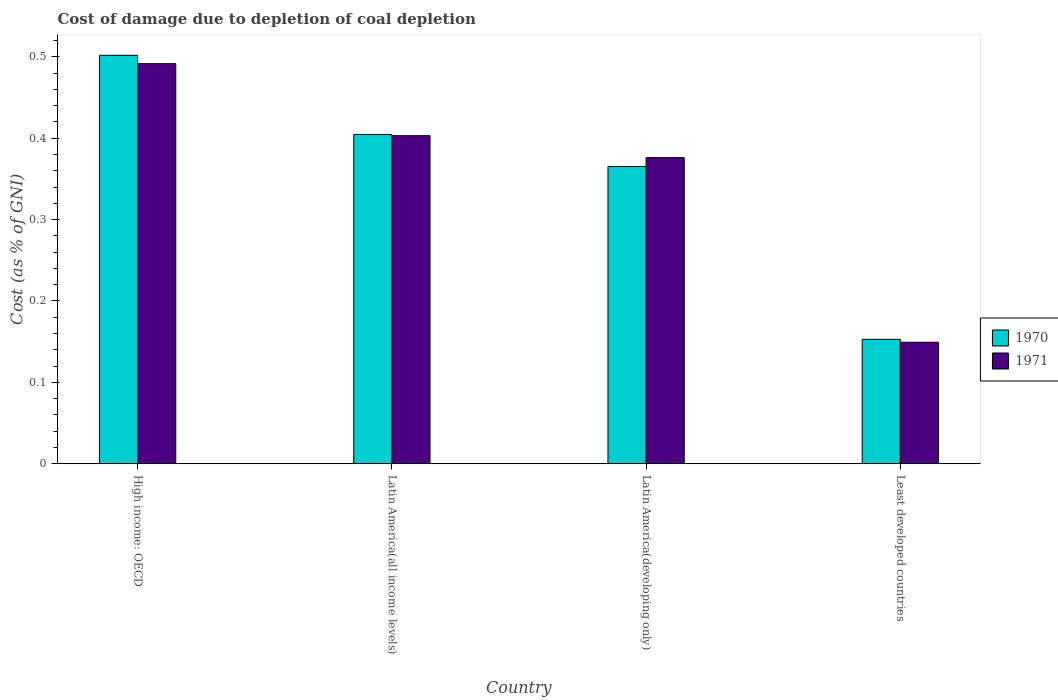How many groups of bars are there?
Ensure brevity in your answer.  4. What is the label of the 3rd group of bars from the left?
Keep it short and to the point. Latin America(developing only). In how many cases, is the number of bars for a given country not equal to the number of legend labels?
Offer a terse response. 0. What is the cost of damage caused due to coal depletion in 1971 in Latin America(all income levels)?
Make the answer very short. 0.4. Across all countries, what is the maximum cost of damage caused due to coal depletion in 1970?
Your answer should be compact. 0.5. Across all countries, what is the minimum cost of damage caused due to coal depletion in 1971?
Provide a succinct answer. 0.15. In which country was the cost of damage caused due to coal depletion in 1970 maximum?
Ensure brevity in your answer.  High income: OECD. In which country was the cost of damage caused due to coal depletion in 1971 minimum?
Ensure brevity in your answer.  Least developed countries. What is the total cost of damage caused due to coal depletion in 1971 in the graph?
Offer a very short reply. 1.42. What is the difference between the cost of damage caused due to coal depletion in 1970 in High income: OECD and that in Latin America(developing only)?
Keep it short and to the point. 0.14. What is the difference between the cost of damage caused due to coal depletion in 1970 in Latin America(all income levels) and the cost of damage caused due to coal depletion in 1971 in Latin America(developing only)?
Make the answer very short. 0.03. What is the average cost of damage caused due to coal depletion in 1971 per country?
Give a very brief answer. 0.35. What is the difference between the cost of damage caused due to coal depletion of/in 1970 and cost of damage caused due to coal depletion of/in 1971 in High income: OECD?
Make the answer very short. 0.01. In how many countries, is the cost of damage caused due to coal depletion in 1970 greater than 0.36000000000000004 %?
Ensure brevity in your answer.  3. What is the ratio of the cost of damage caused due to coal depletion in 1971 in Latin America(developing only) to that in Least developed countries?
Keep it short and to the point. 2.52. Is the cost of damage caused due to coal depletion in 1970 in High income: OECD less than that in Least developed countries?
Provide a short and direct response. No. What is the difference between the highest and the second highest cost of damage caused due to coal depletion in 1970?
Make the answer very short. 0.1. What is the difference between the highest and the lowest cost of damage caused due to coal depletion in 1971?
Your response must be concise. 0.34. In how many countries, is the cost of damage caused due to coal depletion in 1970 greater than the average cost of damage caused due to coal depletion in 1970 taken over all countries?
Offer a very short reply. 3. What does the 1st bar from the left in Least developed countries represents?
Your answer should be very brief. 1970. What does the 1st bar from the right in Latin America(developing only) represents?
Provide a succinct answer. 1971. How many bars are there?
Provide a short and direct response. 8. Are all the bars in the graph horizontal?
Offer a very short reply. No. How many countries are there in the graph?
Your answer should be compact. 4. Does the graph contain any zero values?
Give a very brief answer. No. Does the graph contain grids?
Your response must be concise. No. How many legend labels are there?
Your answer should be compact. 2. How are the legend labels stacked?
Give a very brief answer. Vertical. What is the title of the graph?
Provide a short and direct response. Cost of damage due to depletion of coal depletion. What is the label or title of the Y-axis?
Offer a very short reply. Cost (as % of GNI). What is the Cost (as % of GNI) of 1970 in High income: OECD?
Make the answer very short. 0.5. What is the Cost (as % of GNI) of 1971 in High income: OECD?
Ensure brevity in your answer.  0.49. What is the Cost (as % of GNI) in 1970 in Latin America(all income levels)?
Ensure brevity in your answer.  0.4. What is the Cost (as % of GNI) in 1971 in Latin America(all income levels)?
Offer a terse response. 0.4. What is the Cost (as % of GNI) of 1970 in Latin America(developing only)?
Provide a succinct answer. 0.37. What is the Cost (as % of GNI) of 1971 in Latin America(developing only)?
Keep it short and to the point. 0.38. What is the Cost (as % of GNI) in 1970 in Least developed countries?
Give a very brief answer. 0.15. What is the Cost (as % of GNI) in 1971 in Least developed countries?
Offer a very short reply. 0.15. Across all countries, what is the maximum Cost (as % of GNI) of 1970?
Your answer should be compact. 0.5. Across all countries, what is the maximum Cost (as % of GNI) of 1971?
Make the answer very short. 0.49. Across all countries, what is the minimum Cost (as % of GNI) in 1970?
Make the answer very short. 0.15. Across all countries, what is the minimum Cost (as % of GNI) in 1971?
Your answer should be compact. 0.15. What is the total Cost (as % of GNI) in 1970 in the graph?
Offer a terse response. 1.42. What is the total Cost (as % of GNI) in 1971 in the graph?
Ensure brevity in your answer.  1.42. What is the difference between the Cost (as % of GNI) in 1970 in High income: OECD and that in Latin America(all income levels)?
Offer a very short reply. 0.1. What is the difference between the Cost (as % of GNI) in 1971 in High income: OECD and that in Latin America(all income levels)?
Your answer should be compact. 0.09. What is the difference between the Cost (as % of GNI) of 1970 in High income: OECD and that in Latin America(developing only)?
Provide a short and direct response. 0.14. What is the difference between the Cost (as % of GNI) in 1971 in High income: OECD and that in Latin America(developing only)?
Your response must be concise. 0.12. What is the difference between the Cost (as % of GNI) in 1970 in High income: OECD and that in Least developed countries?
Your answer should be compact. 0.35. What is the difference between the Cost (as % of GNI) of 1971 in High income: OECD and that in Least developed countries?
Provide a short and direct response. 0.34. What is the difference between the Cost (as % of GNI) in 1970 in Latin America(all income levels) and that in Latin America(developing only)?
Offer a terse response. 0.04. What is the difference between the Cost (as % of GNI) of 1971 in Latin America(all income levels) and that in Latin America(developing only)?
Offer a terse response. 0.03. What is the difference between the Cost (as % of GNI) of 1970 in Latin America(all income levels) and that in Least developed countries?
Offer a terse response. 0.25. What is the difference between the Cost (as % of GNI) in 1971 in Latin America(all income levels) and that in Least developed countries?
Keep it short and to the point. 0.25. What is the difference between the Cost (as % of GNI) in 1970 in Latin America(developing only) and that in Least developed countries?
Offer a terse response. 0.21. What is the difference between the Cost (as % of GNI) in 1971 in Latin America(developing only) and that in Least developed countries?
Provide a succinct answer. 0.23. What is the difference between the Cost (as % of GNI) of 1970 in High income: OECD and the Cost (as % of GNI) of 1971 in Latin America(all income levels)?
Your answer should be compact. 0.1. What is the difference between the Cost (as % of GNI) of 1970 in High income: OECD and the Cost (as % of GNI) of 1971 in Latin America(developing only)?
Offer a very short reply. 0.13. What is the difference between the Cost (as % of GNI) of 1970 in High income: OECD and the Cost (as % of GNI) of 1971 in Least developed countries?
Make the answer very short. 0.35. What is the difference between the Cost (as % of GNI) in 1970 in Latin America(all income levels) and the Cost (as % of GNI) in 1971 in Latin America(developing only)?
Offer a very short reply. 0.03. What is the difference between the Cost (as % of GNI) in 1970 in Latin America(all income levels) and the Cost (as % of GNI) in 1971 in Least developed countries?
Provide a short and direct response. 0.26. What is the difference between the Cost (as % of GNI) of 1970 in Latin America(developing only) and the Cost (as % of GNI) of 1971 in Least developed countries?
Provide a short and direct response. 0.22. What is the average Cost (as % of GNI) of 1970 per country?
Provide a succinct answer. 0.36. What is the average Cost (as % of GNI) of 1971 per country?
Provide a succinct answer. 0.35. What is the difference between the Cost (as % of GNI) of 1970 and Cost (as % of GNI) of 1971 in High income: OECD?
Your answer should be very brief. 0.01. What is the difference between the Cost (as % of GNI) in 1970 and Cost (as % of GNI) in 1971 in Latin America(all income levels)?
Give a very brief answer. 0. What is the difference between the Cost (as % of GNI) of 1970 and Cost (as % of GNI) of 1971 in Latin America(developing only)?
Make the answer very short. -0.01. What is the difference between the Cost (as % of GNI) in 1970 and Cost (as % of GNI) in 1971 in Least developed countries?
Your answer should be very brief. 0. What is the ratio of the Cost (as % of GNI) in 1970 in High income: OECD to that in Latin America(all income levels)?
Your answer should be very brief. 1.24. What is the ratio of the Cost (as % of GNI) in 1971 in High income: OECD to that in Latin America(all income levels)?
Offer a very short reply. 1.22. What is the ratio of the Cost (as % of GNI) of 1970 in High income: OECD to that in Latin America(developing only)?
Your answer should be compact. 1.37. What is the ratio of the Cost (as % of GNI) in 1971 in High income: OECD to that in Latin America(developing only)?
Give a very brief answer. 1.31. What is the ratio of the Cost (as % of GNI) of 1970 in High income: OECD to that in Least developed countries?
Offer a terse response. 3.28. What is the ratio of the Cost (as % of GNI) of 1971 in High income: OECD to that in Least developed countries?
Provide a short and direct response. 3.29. What is the ratio of the Cost (as % of GNI) in 1970 in Latin America(all income levels) to that in Latin America(developing only)?
Provide a short and direct response. 1.11. What is the ratio of the Cost (as % of GNI) of 1971 in Latin America(all income levels) to that in Latin America(developing only)?
Provide a short and direct response. 1.07. What is the ratio of the Cost (as % of GNI) in 1970 in Latin America(all income levels) to that in Least developed countries?
Provide a short and direct response. 2.65. What is the ratio of the Cost (as % of GNI) of 1971 in Latin America(all income levels) to that in Least developed countries?
Your answer should be compact. 2.7. What is the ratio of the Cost (as % of GNI) in 1970 in Latin America(developing only) to that in Least developed countries?
Provide a short and direct response. 2.39. What is the ratio of the Cost (as % of GNI) of 1971 in Latin America(developing only) to that in Least developed countries?
Provide a short and direct response. 2.52. What is the difference between the highest and the second highest Cost (as % of GNI) of 1970?
Keep it short and to the point. 0.1. What is the difference between the highest and the second highest Cost (as % of GNI) of 1971?
Provide a short and direct response. 0.09. What is the difference between the highest and the lowest Cost (as % of GNI) in 1970?
Provide a succinct answer. 0.35. What is the difference between the highest and the lowest Cost (as % of GNI) in 1971?
Your answer should be compact. 0.34. 